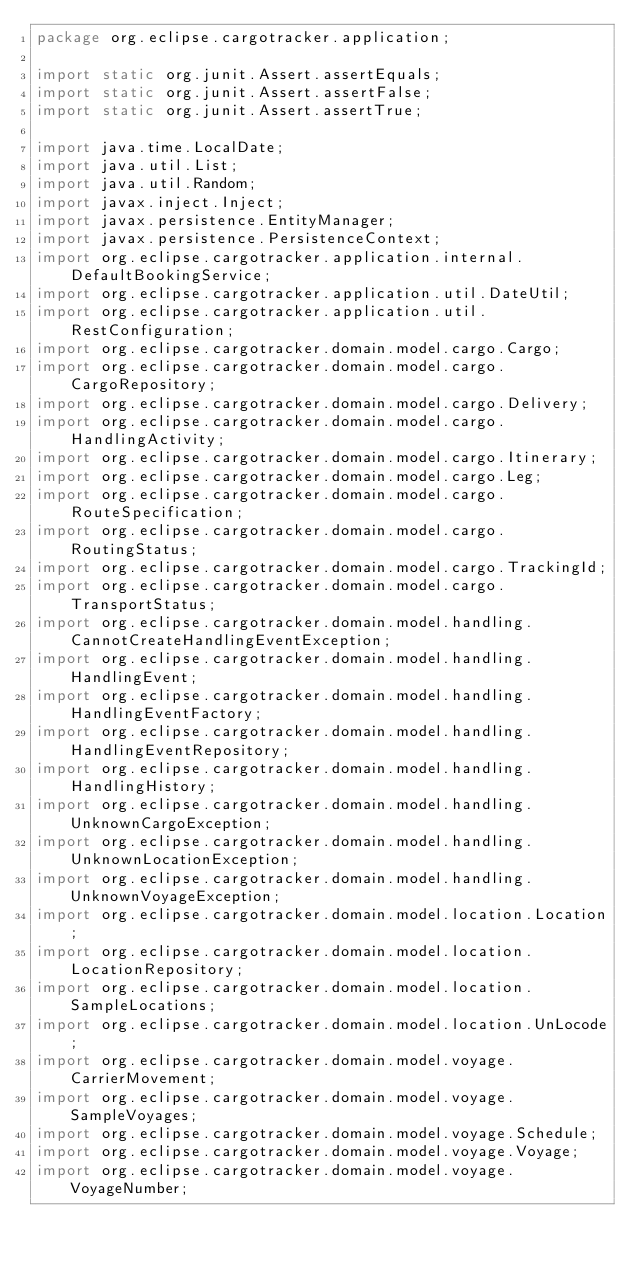Convert code to text. <code><loc_0><loc_0><loc_500><loc_500><_Java_>package org.eclipse.cargotracker.application;

import static org.junit.Assert.assertEquals;
import static org.junit.Assert.assertFalse;
import static org.junit.Assert.assertTrue;

import java.time.LocalDate;
import java.util.List;
import java.util.Random;
import javax.inject.Inject;
import javax.persistence.EntityManager;
import javax.persistence.PersistenceContext;
import org.eclipse.cargotracker.application.internal.DefaultBookingService;
import org.eclipse.cargotracker.application.util.DateUtil;
import org.eclipse.cargotracker.application.util.RestConfiguration;
import org.eclipse.cargotracker.domain.model.cargo.Cargo;
import org.eclipse.cargotracker.domain.model.cargo.CargoRepository;
import org.eclipse.cargotracker.domain.model.cargo.Delivery;
import org.eclipse.cargotracker.domain.model.cargo.HandlingActivity;
import org.eclipse.cargotracker.domain.model.cargo.Itinerary;
import org.eclipse.cargotracker.domain.model.cargo.Leg;
import org.eclipse.cargotracker.domain.model.cargo.RouteSpecification;
import org.eclipse.cargotracker.domain.model.cargo.RoutingStatus;
import org.eclipse.cargotracker.domain.model.cargo.TrackingId;
import org.eclipse.cargotracker.domain.model.cargo.TransportStatus;
import org.eclipse.cargotracker.domain.model.handling.CannotCreateHandlingEventException;
import org.eclipse.cargotracker.domain.model.handling.HandlingEvent;
import org.eclipse.cargotracker.domain.model.handling.HandlingEventFactory;
import org.eclipse.cargotracker.domain.model.handling.HandlingEventRepository;
import org.eclipse.cargotracker.domain.model.handling.HandlingHistory;
import org.eclipse.cargotracker.domain.model.handling.UnknownCargoException;
import org.eclipse.cargotracker.domain.model.handling.UnknownLocationException;
import org.eclipse.cargotracker.domain.model.handling.UnknownVoyageException;
import org.eclipse.cargotracker.domain.model.location.Location;
import org.eclipse.cargotracker.domain.model.location.LocationRepository;
import org.eclipse.cargotracker.domain.model.location.SampleLocations;
import org.eclipse.cargotracker.domain.model.location.UnLocode;
import org.eclipse.cargotracker.domain.model.voyage.CarrierMovement;
import org.eclipse.cargotracker.domain.model.voyage.SampleVoyages;
import org.eclipse.cargotracker.domain.model.voyage.Schedule;
import org.eclipse.cargotracker.domain.model.voyage.Voyage;
import org.eclipse.cargotracker.domain.model.voyage.VoyageNumber;</code> 